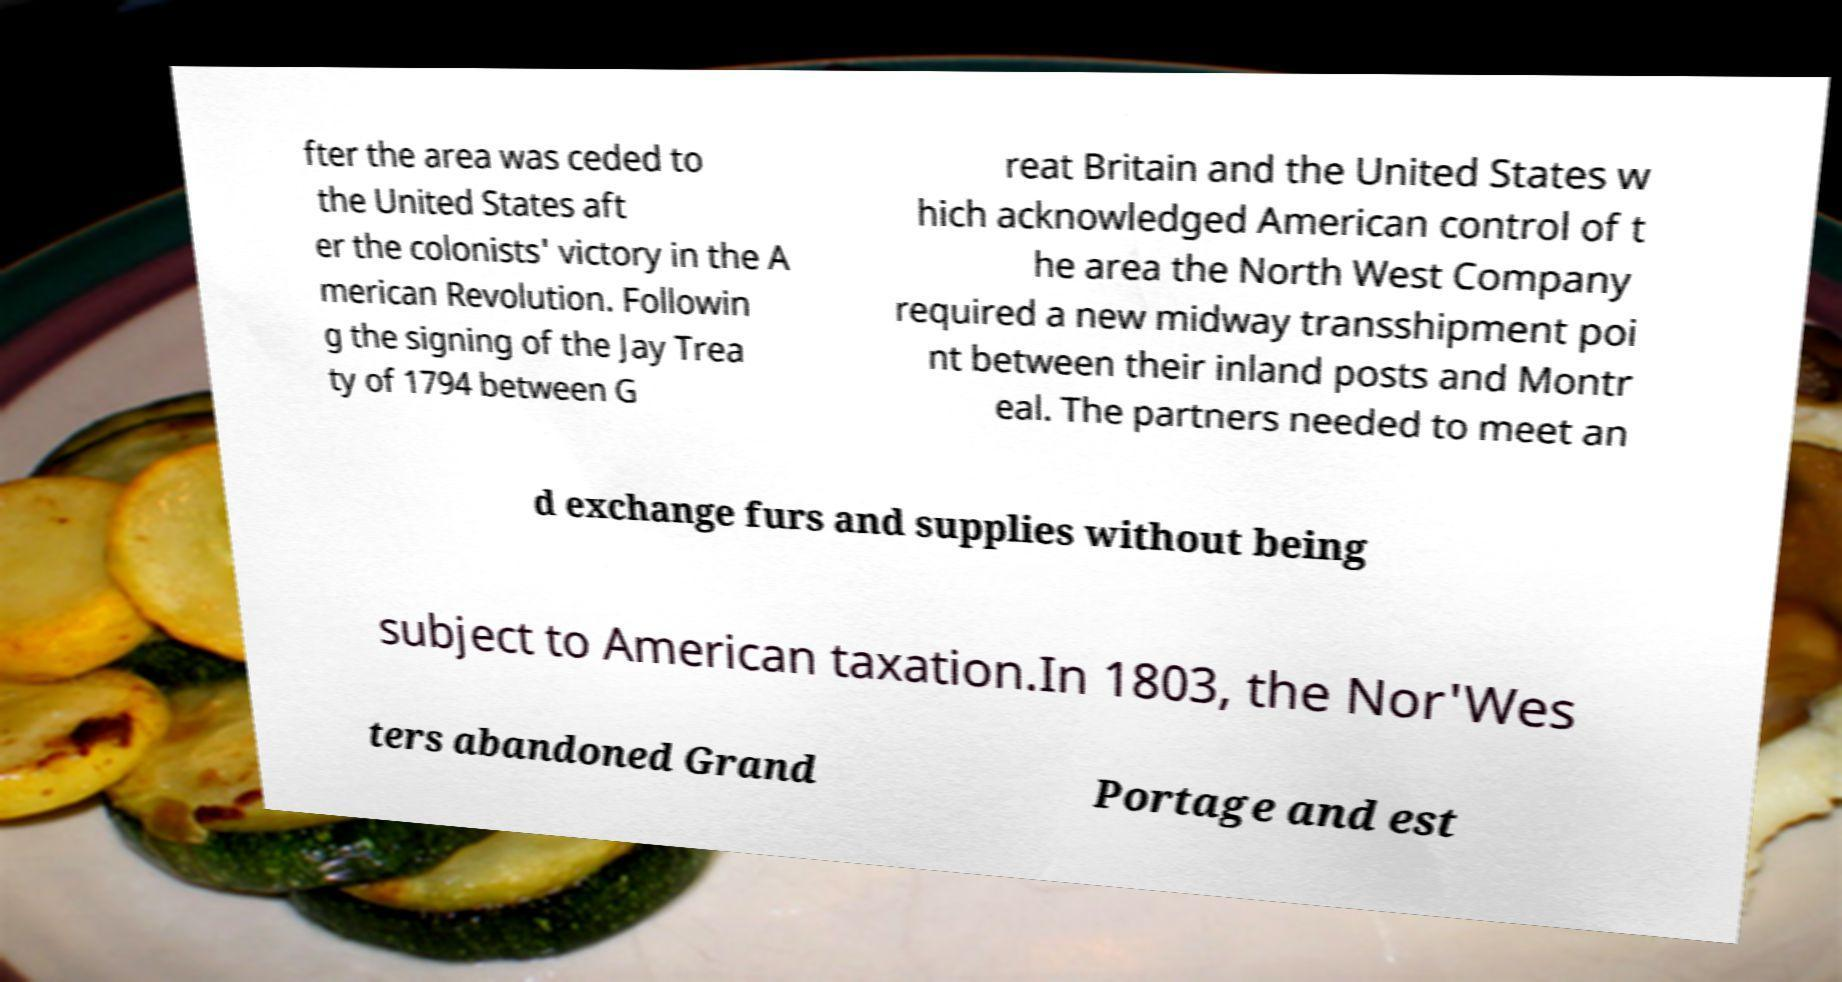Please read and relay the text visible in this image. What does it say? fter the area was ceded to the United States aft er the colonists' victory in the A merican Revolution. Followin g the signing of the Jay Trea ty of 1794 between G reat Britain and the United States w hich acknowledged American control of t he area the North West Company required a new midway transshipment poi nt between their inland posts and Montr eal. The partners needed to meet an d exchange furs and supplies without being subject to American taxation.In 1803, the Nor'Wes ters abandoned Grand Portage and est 